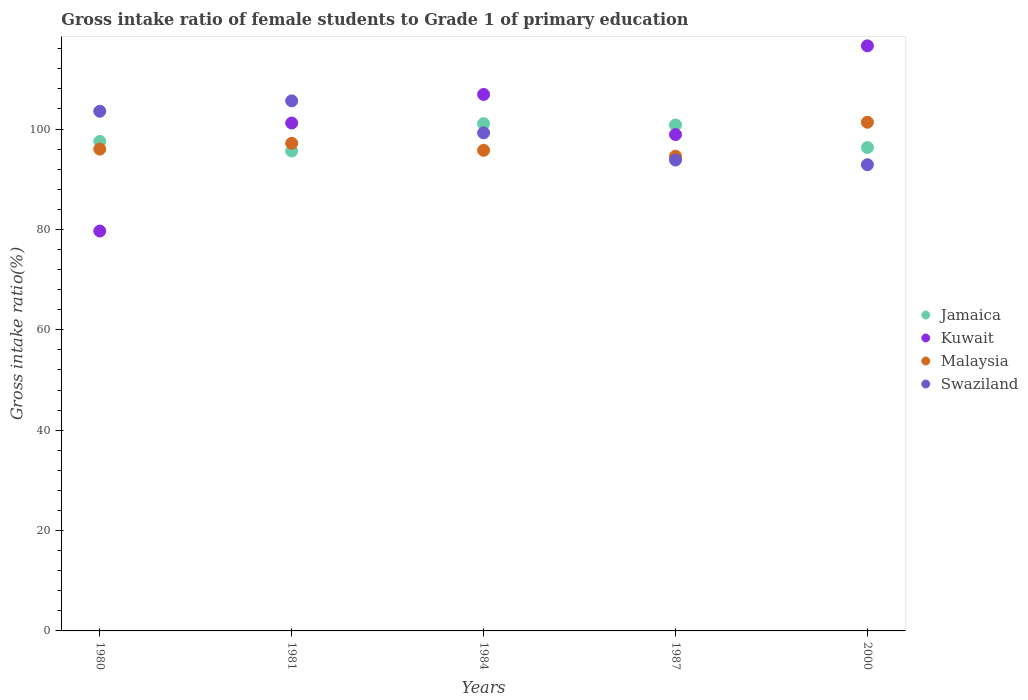Is the number of dotlines equal to the number of legend labels?
Your answer should be compact. Yes. What is the gross intake ratio in Kuwait in 2000?
Your answer should be compact. 116.58. Across all years, what is the maximum gross intake ratio in Jamaica?
Your response must be concise. 101.08. Across all years, what is the minimum gross intake ratio in Malaysia?
Make the answer very short. 94.6. In which year was the gross intake ratio in Jamaica minimum?
Offer a terse response. 1981. What is the total gross intake ratio in Malaysia in the graph?
Provide a short and direct response. 484.9. What is the difference between the gross intake ratio in Kuwait in 1980 and that in 1981?
Keep it short and to the point. -21.52. What is the difference between the gross intake ratio in Swaziland in 1984 and the gross intake ratio in Malaysia in 1987?
Your response must be concise. 4.64. What is the average gross intake ratio in Kuwait per year?
Offer a very short reply. 100.65. In the year 2000, what is the difference between the gross intake ratio in Malaysia and gross intake ratio in Jamaica?
Provide a short and direct response. 5.03. What is the ratio of the gross intake ratio in Malaysia in 1984 to that in 1987?
Your answer should be very brief. 1.01. Is the gross intake ratio in Malaysia in 1984 less than that in 1987?
Make the answer very short. No. What is the difference between the highest and the second highest gross intake ratio in Kuwait?
Your answer should be very brief. 9.68. What is the difference between the highest and the lowest gross intake ratio in Jamaica?
Your response must be concise. 5.44. Is the sum of the gross intake ratio in Kuwait in 1980 and 1981 greater than the maximum gross intake ratio in Jamaica across all years?
Provide a short and direct response. Yes. Is it the case that in every year, the sum of the gross intake ratio in Jamaica and gross intake ratio in Swaziland  is greater than the sum of gross intake ratio in Kuwait and gross intake ratio in Malaysia?
Keep it short and to the point. No. Does the gross intake ratio in Jamaica monotonically increase over the years?
Keep it short and to the point. No. Is the gross intake ratio in Kuwait strictly less than the gross intake ratio in Swaziland over the years?
Offer a terse response. No. How many years are there in the graph?
Your response must be concise. 5. What is the difference between two consecutive major ticks on the Y-axis?
Keep it short and to the point. 20. Does the graph contain any zero values?
Provide a succinct answer. No. Does the graph contain grids?
Provide a short and direct response. No. How are the legend labels stacked?
Your response must be concise. Vertical. What is the title of the graph?
Offer a terse response. Gross intake ratio of female students to Grade 1 of primary education. What is the label or title of the Y-axis?
Ensure brevity in your answer.  Gross intake ratio(%). What is the Gross intake ratio(%) in Jamaica in 1980?
Ensure brevity in your answer.  97.54. What is the Gross intake ratio(%) in Kuwait in 1980?
Offer a terse response. 79.68. What is the Gross intake ratio(%) of Malaysia in 1980?
Your answer should be compact. 96.01. What is the Gross intake ratio(%) in Swaziland in 1980?
Your response must be concise. 103.55. What is the Gross intake ratio(%) in Jamaica in 1981?
Make the answer very short. 95.63. What is the Gross intake ratio(%) of Kuwait in 1981?
Keep it short and to the point. 101.2. What is the Gross intake ratio(%) of Malaysia in 1981?
Ensure brevity in your answer.  97.17. What is the Gross intake ratio(%) in Swaziland in 1981?
Keep it short and to the point. 105.62. What is the Gross intake ratio(%) in Jamaica in 1984?
Your answer should be compact. 101.08. What is the Gross intake ratio(%) in Kuwait in 1984?
Ensure brevity in your answer.  106.9. What is the Gross intake ratio(%) of Malaysia in 1984?
Provide a short and direct response. 95.77. What is the Gross intake ratio(%) of Swaziland in 1984?
Your response must be concise. 99.24. What is the Gross intake ratio(%) of Jamaica in 1987?
Provide a short and direct response. 100.82. What is the Gross intake ratio(%) of Kuwait in 1987?
Give a very brief answer. 98.9. What is the Gross intake ratio(%) of Malaysia in 1987?
Your answer should be very brief. 94.6. What is the Gross intake ratio(%) in Swaziland in 1987?
Provide a short and direct response. 93.83. What is the Gross intake ratio(%) of Jamaica in 2000?
Offer a terse response. 96.33. What is the Gross intake ratio(%) of Kuwait in 2000?
Provide a short and direct response. 116.58. What is the Gross intake ratio(%) of Malaysia in 2000?
Your answer should be very brief. 101.36. What is the Gross intake ratio(%) in Swaziland in 2000?
Your response must be concise. 92.9. Across all years, what is the maximum Gross intake ratio(%) in Jamaica?
Your response must be concise. 101.08. Across all years, what is the maximum Gross intake ratio(%) in Kuwait?
Provide a short and direct response. 116.58. Across all years, what is the maximum Gross intake ratio(%) of Malaysia?
Make the answer very short. 101.36. Across all years, what is the maximum Gross intake ratio(%) of Swaziland?
Your answer should be compact. 105.62. Across all years, what is the minimum Gross intake ratio(%) of Jamaica?
Your response must be concise. 95.63. Across all years, what is the minimum Gross intake ratio(%) in Kuwait?
Offer a terse response. 79.68. Across all years, what is the minimum Gross intake ratio(%) of Malaysia?
Your answer should be very brief. 94.6. Across all years, what is the minimum Gross intake ratio(%) in Swaziland?
Give a very brief answer. 92.9. What is the total Gross intake ratio(%) in Jamaica in the graph?
Make the answer very short. 491.39. What is the total Gross intake ratio(%) in Kuwait in the graph?
Your answer should be very brief. 503.27. What is the total Gross intake ratio(%) in Malaysia in the graph?
Your answer should be compact. 484.9. What is the total Gross intake ratio(%) of Swaziland in the graph?
Give a very brief answer. 495.14. What is the difference between the Gross intake ratio(%) in Jamaica in 1980 and that in 1981?
Offer a terse response. 1.91. What is the difference between the Gross intake ratio(%) in Kuwait in 1980 and that in 1981?
Provide a short and direct response. -21.52. What is the difference between the Gross intake ratio(%) in Malaysia in 1980 and that in 1981?
Your response must be concise. -1.16. What is the difference between the Gross intake ratio(%) in Swaziland in 1980 and that in 1981?
Your response must be concise. -2.06. What is the difference between the Gross intake ratio(%) of Jamaica in 1980 and that in 1984?
Provide a succinct answer. -3.53. What is the difference between the Gross intake ratio(%) of Kuwait in 1980 and that in 1984?
Your answer should be compact. -27.22. What is the difference between the Gross intake ratio(%) of Malaysia in 1980 and that in 1984?
Provide a succinct answer. 0.24. What is the difference between the Gross intake ratio(%) of Swaziland in 1980 and that in 1984?
Make the answer very short. 4.31. What is the difference between the Gross intake ratio(%) of Jamaica in 1980 and that in 1987?
Ensure brevity in your answer.  -3.27. What is the difference between the Gross intake ratio(%) in Kuwait in 1980 and that in 1987?
Give a very brief answer. -19.22. What is the difference between the Gross intake ratio(%) in Malaysia in 1980 and that in 1987?
Offer a very short reply. 1.4. What is the difference between the Gross intake ratio(%) in Swaziland in 1980 and that in 1987?
Offer a very short reply. 9.72. What is the difference between the Gross intake ratio(%) of Jamaica in 1980 and that in 2000?
Give a very brief answer. 1.21. What is the difference between the Gross intake ratio(%) in Kuwait in 1980 and that in 2000?
Your answer should be very brief. -36.9. What is the difference between the Gross intake ratio(%) in Malaysia in 1980 and that in 2000?
Give a very brief answer. -5.35. What is the difference between the Gross intake ratio(%) in Swaziland in 1980 and that in 2000?
Provide a succinct answer. 10.66. What is the difference between the Gross intake ratio(%) in Jamaica in 1981 and that in 1984?
Offer a terse response. -5.44. What is the difference between the Gross intake ratio(%) in Kuwait in 1981 and that in 1984?
Offer a very short reply. -5.7. What is the difference between the Gross intake ratio(%) in Malaysia in 1981 and that in 1984?
Ensure brevity in your answer.  1.4. What is the difference between the Gross intake ratio(%) in Swaziland in 1981 and that in 1984?
Provide a short and direct response. 6.37. What is the difference between the Gross intake ratio(%) of Jamaica in 1981 and that in 1987?
Your answer should be compact. -5.19. What is the difference between the Gross intake ratio(%) in Kuwait in 1981 and that in 1987?
Offer a terse response. 2.3. What is the difference between the Gross intake ratio(%) in Malaysia in 1981 and that in 1987?
Provide a short and direct response. 2.57. What is the difference between the Gross intake ratio(%) of Swaziland in 1981 and that in 1987?
Give a very brief answer. 11.79. What is the difference between the Gross intake ratio(%) of Jamaica in 1981 and that in 2000?
Ensure brevity in your answer.  -0.7. What is the difference between the Gross intake ratio(%) in Kuwait in 1981 and that in 2000?
Your response must be concise. -15.38. What is the difference between the Gross intake ratio(%) in Malaysia in 1981 and that in 2000?
Offer a terse response. -4.19. What is the difference between the Gross intake ratio(%) in Swaziland in 1981 and that in 2000?
Offer a terse response. 12.72. What is the difference between the Gross intake ratio(%) in Jamaica in 1984 and that in 1987?
Keep it short and to the point. 0.26. What is the difference between the Gross intake ratio(%) in Kuwait in 1984 and that in 1987?
Provide a short and direct response. 8. What is the difference between the Gross intake ratio(%) in Malaysia in 1984 and that in 1987?
Offer a very short reply. 1.16. What is the difference between the Gross intake ratio(%) of Swaziland in 1984 and that in 1987?
Provide a succinct answer. 5.41. What is the difference between the Gross intake ratio(%) of Jamaica in 1984 and that in 2000?
Keep it short and to the point. 4.75. What is the difference between the Gross intake ratio(%) of Kuwait in 1984 and that in 2000?
Offer a very short reply. -9.68. What is the difference between the Gross intake ratio(%) in Malaysia in 1984 and that in 2000?
Ensure brevity in your answer.  -5.59. What is the difference between the Gross intake ratio(%) of Swaziland in 1984 and that in 2000?
Your answer should be compact. 6.35. What is the difference between the Gross intake ratio(%) of Jamaica in 1987 and that in 2000?
Make the answer very short. 4.49. What is the difference between the Gross intake ratio(%) in Kuwait in 1987 and that in 2000?
Give a very brief answer. -17.69. What is the difference between the Gross intake ratio(%) of Malaysia in 1987 and that in 2000?
Offer a terse response. -6.75. What is the difference between the Gross intake ratio(%) in Swaziland in 1987 and that in 2000?
Keep it short and to the point. 0.94. What is the difference between the Gross intake ratio(%) of Jamaica in 1980 and the Gross intake ratio(%) of Kuwait in 1981?
Offer a terse response. -3.66. What is the difference between the Gross intake ratio(%) of Jamaica in 1980 and the Gross intake ratio(%) of Malaysia in 1981?
Your answer should be very brief. 0.37. What is the difference between the Gross intake ratio(%) of Jamaica in 1980 and the Gross intake ratio(%) of Swaziland in 1981?
Offer a very short reply. -8.08. What is the difference between the Gross intake ratio(%) in Kuwait in 1980 and the Gross intake ratio(%) in Malaysia in 1981?
Offer a terse response. -17.49. What is the difference between the Gross intake ratio(%) of Kuwait in 1980 and the Gross intake ratio(%) of Swaziland in 1981?
Provide a succinct answer. -25.94. What is the difference between the Gross intake ratio(%) in Malaysia in 1980 and the Gross intake ratio(%) in Swaziland in 1981?
Give a very brief answer. -9.61. What is the difference between the Gross intake ratio(%) of Jamaica in 1980 and the Gross intake ratio(%) of Kuwait in 1984?
Ensure brevity in your answer.  -9.36. What is the difference between the Gross intake ratio(%) of Jamaica in 1980 and the Gross intake ratio(%) of Malaysia in 1984?
Your answer should be very brief. 1.77. What is the difference between the Gross intake ratio(%) in Jamaica in 1980 and the Gross intake ratio(%) in Swaziland in 1984?
Offer a terse response. -1.7. What is the difference between the Gross intake ratio(%) in Kuwait in 1980 and the Gross intake ratio(%) in Malaysia in 1984?
Ensure brevity in your answer.  -16.09. What is the difference between the Gross intake ratio(%) in Kuwait in 1980 and the Gross intake ratio(%) in Swaziland in 1984?
Ensure brevity in your answer.  -19.56. What is the difference between the Gross intake ratio(%) in Malaysia in 1980 and the Gross intake ratio(%) in Swaziland in 1984?
Your response must be concise. -3.24. What is the difference between the Gross intake ratio(%) in Jamaica in 1980 and the Gross intake ratio(%) in Kuwait in 1987?
Give a very brief answer. -1.36. What is the difference between the Gross intake ratio(%) in Jamaica in 1980 and the Gross intake ratio(%) in Malaysia in 1987?
Provide a succinct answer. 2.94. What is the difference between the Gross intake ratio(%) of Jamaica in 1980 and the Gross intake ratio(%) of Swaziland in 1987?
Make the answer very short. 3.71. What is the difference between the Gross intake ratio(%) in Kuwait in 1980 and the Gross intake ratio(%) in Malaysia in 1987?
Provide a short and direct response. -14.92. What is the difference between the Gross intake ratio(%) of Kuwait in 1980 and the Gross intake ratio(%) of Swaziland in 1987?
Give a very brief answer. -14.15. What is the difference between the Gross intake ratio(%) in Malaysia in 1980 and the Gross intake ratio(%) in Swaziland in 1987?
Ensure brevity in your answer.  2.17. What is the difference between the Gross intake ratio(%) in Jamaica in 1980 and the Gross intake ratio(%) in Kuwait in 2000?
Give a very brief answer. -19.04. What is the difference between the Gross intake ratio(%) of Jamaica in 1980 and the Gross intake ratio(%) of Malaysia in 2000?
Give a very brief answer. -3.82. What is the difference between the Gross intake ratio(%) in Jamaica in 1980 and the Gross intake ratio(%) in Swaziland in 2000?
Provide a short and direct response. 4.65. What is the difference between the Gross intake ratio(%) in Kuwait in 1980 and the Gross intake ratio(%) in Malaysia in 2000?
Provide a succinct answer. -21.68. What is the difference between the Gross intake ratio(%) in Kuwait in 1980 and the Gross intake ratio(%) in Swaziland in 2000?
Make the answer very short. -13.21. What is the difference between the Gross intake ratio(%) in Malaysia in 1980 and the Gross intake ratio(%) in Swaziland in 2000?
Keep it short and to the point. 3.11. What is the difference between the Gross intake ratio(%) in Jamaica in 1981 and the Gross intake ratio(%) in Kuwait in 1984?
Provide a short and direct response. -11.27. What is the difference between the Gross intake ratio(%) of Jamaica in 1981 and the Gross intake ratio(%) of Malaysia in 1984?
Your answer should be compact. -0.14. What is the difference between the Gross intake ratio(%) in Jamaica in 1981 and the Gross intake ratio(%) in Swaziland in 1984?
Provide a short and direct response. -3.61. What is the difference between the Gross intake ratio(%) of Kuwait in 1981 and the Gross intake ratio(%) of Malaysia in 1984?
Keep it short and to the point. 5.44. What is the difference between the Gross intake ratio(%) in Kuwait in 1981 and the Gross intake ratio(%) in Swaziland in 1984?
Make the answer very short. 1.96. What is the difference between the Gross intake ratio(%) of Malaysia in 1981 and the Gross intake ratio(%) of Swaziland in 1984?
Offer a terse response. -2.08. What is the difference between the Gross intake ratio(%) in Jamaica in 1981 and the Gross intake ratio(%) in Kuwait in 1987?
Keep it short and to the point. -3.27. What is the difference between the Gross intake ratio(%) of Jamaica in 1981 and the Gross intake ratio(%) of Malaysia in 1987?
Give a very brief answer. 1.03. What is the difference between the Gross intake ratio(%) in Jamaica in 1981 and the Gross intake ratio(%) in Swaziland in 1987?
Provide a succinct answer. 1.8. What is the difference between the Gross intake ratio(%) of Kuwait in 1981 and the Gross intake ratio(%) of Swaziland in 1987?
Provide a succinct answer. 7.37. What is the difference between the Gross intake ratio(%) in Malaysia in 1981 and the Gross intake ratio(%) in Swaziland in 1987?
Your response must be concise. 3.34. What is the difference between the Gross intake ratio(%) of Jamaica in 1981 and the Gross intake ratio(%) of Kuwait in 2000?
Offer a very short reply. -20.95. What is the difference between the Gross intake ratio(%) of Jamaica in 1981 and the Gross intake ratio(%) of Malaysia in 2000?
Offer a terse response. -5.73. What is the difference between the Gross intake ratio(%) of Jamaica in 1981 and the Gross intake ratio(%) of Swaziland in 2000?
Offer a terse response. 2.73. What is the difference between the Gross intake ratio(%) of Kuwait in 1981 and the Gross intake ratio(%) of Malaysia in 2000?
Offer a terse response. -0.15. What is the difference between the Gross intake ratio(%) in Kuwait in 1981 and the Gross intake ratio(%) in Swaziland in 2000?
Provide a short and direct response. 8.31. What is the difference between the Gross intake ratio(%) of Malaysia in 1981 and the Gross intake ratio(%) of Swaziland in 2000?
Your answer should be very brief. 4.27. What is the difference between the Gross intake ratio(%) of Jamaica in 1984 and the Gross intake ratio(%) of Kuwait in 1987?
Your answer should be compact. 2.18. What is the difference between the Gross intake ratio(%) of Jamaica in 1984 and the Gross intake ratio(%) of Malaysia in 1987?
Keep it short and to the point. 6.47. What is the difference between the Gross intake ratio(%) in Jamaica in 1984 and the Gross intake ratio(%) in Swaziland in 1987?
Offer a very short reply. 7.24. What is the difference between the Gross intake ratio(%) in Kuwait in 1984 and the Gross intake ratio(%) in Malaysia in 1987?
Give a very brief answer. 12.3. What is the difference between the Gross intake ratio(%) in Kuwait in 1984 and the Gross intake ratio(%) in Swaziland in 1987?
Make the answer very short. 13.07. What is the difference between the Gross intake ratio(%) in Malaysia in 1984 and the Gross intake ratio(%) in Swaziland in 1987?
Your answer should be very brief. 1.93. What is the difference between the Gross intake ratio(%) in Jamaica in 1984 and the Gross intake ratio(%) in Kuwait in 2000?
Provide a succinct answer. -15.51. What is the difference between the Gross intake ratio(%) of Jamaica in 1984 and the Gross intake ratio(%) of Malaysia in 2000?
Make the answer very short. -0.28. What is the difference between the Gross intake ratio(%) of Jamaica in 1984 and the Gross intake ratio(%) of Swaziland in 2000?
Keep it short and to the point. 8.18. What is the difference between the Gross intake ratio(%) in Kuwait in 1984 and the Gross intake ratio(%) in Malaysia in 2000?
Ensure brevity in your answer.  5.54. What is the difference between the Gross intake ratio(%) in Kuwait in 1984 and the Gross intake ratio(%) in Swaziland in 2000?
Your response must be concise. 14. What is the difference between the Gross intake ratio(%) of Malaysia in 1984 and the Gross intake ratio(%) of Swaziland in 2000?
Offer a terse response. 2.87. What is the difference between the Gross intake ratio(%) in Jamaica in 1987 and the Gross intake ratio(%) in Kuwait in 2000?
Offer a very short reply. -15.77. What is the difference between the Gross intake ratio(%) of Jamaica in 1987 and the Gross intake ratio(%) of Malaysia in 2000?
Your answer should be compact. -0.54. What is the difference between the Gross intake ratio(%) of Jamaica in 1987 and the Gross intake ratio(%) of Swaziland in 2000?
Ensure brevity in your answer.  7.92. What is the difference between the Gross intake ratio(%) in Kuwait in 1987 and the Gross intake ratio(%) in Malaysia in 2000?
Provide a short and direct response. -2.46. What is the difference between the Gross intake ratio(%) in Kuwait in 1987 and the Gross intake ratio(%) in Swaziland in 2000?
Offer a very short reply. 6. What is the difference between the Gross intake ratio(%) in Malaysia in 1987 and the Gross intake ratio(%) in Swaziland in 2000?
Offer a very short reply. 1.71. What is the average Gross intake ratio(%) of Jamaica per year?
Ensure brevity in your answer.  98.28. What is the average Gross intake ratio(%) in Kuwait per year?
Your answer should be very brief. 100.65. What is the average Gross intake ratio(%) in Malaysia per year?
Offer a terse response. 96.98. What is the average Gross intake ratio(%) of Swaziland per year?
Provide a succinct answer. 99.03. In the year 1980, what is the difference between the Gross intake ratio(%) in Jamaica and Gross intake ratio(%) in Kuwait?
Your response must be concise. 17.86. In the year 1980, what is the difference between the Gross intake ratio(%) in Jamaica and Gross intake ratio(%) in Malaysia?
Your answer should be very brief. 1.53. In the year 1980, what is the difference between the Gross intake ratio(%) in Jamaica and Gross intake ratio(%) in Swaziland?
Offer a very short reply. -6.01. In the year 1980, what is the difference between the Gross intake ratio(%) of Kuwait and Gross intake ratio(%) of Malaysia?
Offer a very short reply. -16.32. In the year 1980, what is the difference between the Gross intake ratio(%) of Kuwait and Gross intake ratio(%) of Swaziland?
Your answer should be very brief. -23.87. In the year 1980, what is the difference between the Gross intake ratio(%) in Malaysia and Gross intake ratio(%) in Swaziland?
Your response must be concise. -7.55. In the year 1981, what is the difference between the Gross intake ratio(%) of Jamaica and Gross intake ratio(%) of Kuwait?
Offer a very short reply. -5.57. In the year 1981, what is the difference between the Gross intake ratio(%) in Jamaica and Gross intake ratio(%) in Malaysia?
Your answer should be very brief. -1.54. In the year 1981, what is the difference between the Gross intake ratio(%) of Jamaica and Gross intake ratio(%) of Swaziland?
Provide a succinct answer. -9.99. In the year 1981, what is the difference between the Gross intake ratio(%) in Kuwait and Gross intake ratio(%) in Malaysia?
Offer a very short reply. 4.03. In the year 1981, what is the difference between the Gross intake ratio(%) of Kuwait and Gross intake ratio(%) of Swaziland?
Give a very brief answer. -4.41. In the year 1981, what is the difference between the Gross intake ratio(%) in Malaysia and Gross intake ratio(%) in Swaziland?
Ensure brevity in your answer.  -8.45. In the year 1984, what is the difference between the Gross intake ratio(%) of Jamaica and Gross intake ratio(%) of Kuwait?
Provide a succinct answer. -5.82. In the year 1984, what is the difference between the Gross intake ratio(%) of Jamaica and Gross intake ratio(%) of Malaysia?
Ensure brevity in your answer.  5.31. In the year 1984, what is the difference between the Gross intake ratio(%) of Jamaica and Gross intake ratio(%) of Swaziland?
Keep it short and to the point. 1.83. In the year 1984, what is the difference between the Gross intake ratio(%) of Kuwait and Gross intake ratio(%) of Malaysia?
Provide a short and direct response. 11.13. In the year 1984, what is the difference between the Gross intake ratio(%) in Kuwait and Gross intake ratio(%) in Swaziland?
Your answer should be compact. 7.65. In the year 1984, what is the difference between the Gross intake ratio(%) in Malaysia and Gross intake ratio(%) in Swaziland?
Ensure brevity in your answer.  -3.48. In the year 1987, what is the difference between the Gross intake ratio(%) in Jamaica and Gross intake ratio(%) in Kuwait?
Give a very brief answer. 1.92. In the year 1987, what is the difference between the Gross intake ratio(%) in Jamaica and Gross intake ratio(%) in Malaysia?
Provide a short and direct response. 6.21. In the year 1987, what is the difference between the Gross intake ratio(%) in Jamaica and Gross intake ratio(%) in Swaziland?
Your response must be concise. 6.98. In the year 1987, what is the difference between the Gross intake ratio(%) in Kuwait and Gross intake ratio(%) in Malaysia?
Give a very brief answer. 4.3. In the year 1987, what is the difference between the Gross intake ratio(%) of Kuwait and Gross intake ratio(%) of Swaziland?
Your answer should be compact. 5.07. In the year 1987, what is the difference between the Gross intake ratio(%) in Malaysia and Gross intake ratio(%) in Swaziland?
Give a very brief answer. 0.77. In the year 2000, what is the difference between the Gross intake ratio(%) in Jamaica and Gross intake ratio(%) in Kuwait?
Offer a very short reply. -20.26. In the year 2000, what is the difference between the Gross intake ratio(%) of Jamaica and Gross intake ratio(%) of Malaysia?
Your answer should be compact. -5.03. In the year 2000, what is the difference between the Gross intake ratio(%) of Jamaica and Gross intake ratio(%) of Swaziland?
Keep it short and to the point. 3.43. In the year 2000, what is the difference between the Gross intake ratio(%) in Kuwait and Gross intake ratio(%) in Malaysia?
Make the answer very short. 15.23. In the year 2000, what is the difference between the Gross intake ratio(%) in Kuwait and Gross intake ratio(%) in Swaziland?
Keep it short and to the point. 23.69. In the year 2000, what is the difference between the Gross intake ratio(%) of Malaysia and Gross intake ratio(%) of Swaziland?
Give a very brief answer. 8.46. What is the ratio of the Gross intake ratio(%) in Jamaica in 1980 to that in 1981?
Provide a succinct answer. 1.02. What is the ratio of the Gross intake ratio(%) in Kuwait in 1980 to that in 1981?
Ensure brevity in your answer.  0.79. What is the ratio of the Gross intake ratio(%) of Malaysia in 1980 to that in 1981?
Your answer should be compact. 0.99. What is the ratio of the Gross intake ratio(%) in Swaziland in 1980 to that in 1981?
Your response must be concise. 0.98. What is the ratio of the Gross intake ratio(%) of Kuwait in 1980 to that in 1984?
Your answer should be very brief. 0.75. What is the ratio of the Gross intake ratio(%) of Swaziland in 1980 to that in 1984?
Give a very brief answer. 1.04. What is the ratio of the Gross intake ratio(%) of Jamaica in 1980 to that in 1987?
Ensure brevity in your answer.  0.97. What is the ratio of the Gross intake ratio(%) in Kuwait in 1980 to that in 1987?
Ensure brevity in your answer.  0.81. What is the ratio of the Gross intake ratio(%) in Malaysia in 1980 to that in 1987?
Give a very brief answer. 1.01. What is the ratio of the Gross intake ratio(%) of Swaziland in 1980 to that in 1987?
Give a very brief answer. 1.1. What is the ratio of the Gross intake ratio(%) of Jamaica in 1980 to that in 2000?
Keep it short and to the point. 1.01. What is the ratio of the Gross intake ratio(%) of Kuwait in 1980 to that in 2000?
Offer a terse response. 0.68. What is the ratio of the Gross intake ratio(%) in Malaysia in 1980 to that in 2000?
Your answer should be very brief. 0.95. What is the ratio of the Gross intake ratio(%) of Swaziland in 1980 to that in 2000?
Provide a succinct answer. 1.11. What is the ratio of the Gross intake ratio(%) of Jamaica in 1981 to that in 1984?
Give a very brief answer. 0.95. What is the ratio of the Gross intake ratio(%) in Kuwait in 1981 to that in 1984?
Your response must be concise. 0.95. What is the ratio of the Gross intake ratio(%) of Malaysia in 1981 to that in 1984?
Offer a very short reply. 1.01. What is the ratio of the Gross intake ratio(%) in Swaziland in 1981 to that in 1984?
Provide a succinct answer. 1.06. What is the ratio of the Gross intake ratio(%) of Jamaica in 1981 to that in 1987?
Your answer should be very brief. 0.95. What is the ratio of the Gross intake ratio(%) of Kuwait in 1981 to that in 1987?
Make the answer very short. 1.02. What is the ratio of the Gross intake ratio(%) in Malaysia in 1981 to that in 1987?
Keep it short and to the point. 1.03. What is the ratio of the Gross intake ratio(%) of Swaziland in 1981 to that in 1987?
Provide a short and direct response. 1.13. What is the ratio of the Gross intake ratio(%) of Kuwait in 1981 to that in 2000?
Offer a terse response. 0.87. What is the ratio of the Gross intake ratio(%) in Malaysia in 1981 to that in 2000?
Provide a short and direct response. 0.96. What is the ratio of the Gross intake ratio(%) of Swaziland in 1981 to that in 2000?
Ensure brevity in your answer.  1.14. What is the ratio of the Gross intake ratio(%) of Jamaica in 1984 to that in 1987?
Your answer should be very brief. 1. What is the ratio of the Gross intake ratio(%) in Kuwait in 1984 to that in 1987?
Give a very brief answer. 1.08. What is the ratio of the Gross intake ratio(%) of Malaysia in 1984 to that in 1987?
Provide a succinct answer. 1.01. What is the ratio of the Gross intake ratio(%) in Swaziland in 1984 to that in 1987?
Provide a short and direct response. 1.06. What is the ratio of the Gross intake ratio(%) in Jamaica in 1984 to that in 2000?
Give a very brief answer. 1.05. What is the ratio of the Gross intake ratio(%) of Kuwait in 1984 to that in 2000?
Your answer should be very brief. 0.92. What is the ratio of the Gross intake ratio(%) of Malaysia in 1984 to that in 2000?
Make the answer very short. 0.94. What is the ratio of the Gross intake ratio(%) of Swaziland in 1984 to that in 2000?
Keep it short and to the point. 1.07. What is the ratio of the Gross intake ratio(%) in Jamaica in 1987 to that in 2000?
Provide a succinct answer. 1.05. What is the ratio of the Gross intake ratio(%) of Kuwait in 1987 to that in 2000?
Provide a succinct answer. 0.85. What is the ratio of the Gross intake ratio(%) in Malaysia in 1987 to that in 2000?
Give a very brief answer. 0.93. What is the difference between the highest and the second highest Gross intake ratio(%) of Jamaica?
Provide a succinct answer. 0.26. What is the difference between the highest and the second highest Gross intake ratio(%) in Kuwait?
Ensure brevity in your answer.  9.68. What is the difference between the highest and the second highest Gross intake ratio(%) in Malaysia?
Your answer should be very brief. 4.19. What is the difference between the highest and the second highest Gross intake ratio(%) in Swaziland?
Keep it short and to the point. 2.06. What is the difference between the highest and the lowest Gross intake ratio(%) of Jamaica?
Offer a terse response. 5.44. What is the difference between the highest and the lowest Gross intake ratio(%) of Kuwait?
Provide a succinct answer. 36.9. What is the difference between the highest and the lowest Gross intake ratio(%) of Malaysia?
Your response must be concise. 6.75. What is the difference between the highest and the lowest Gross intake ratio(%) in Swaziland?
Your answer should be compact. 12.72. 